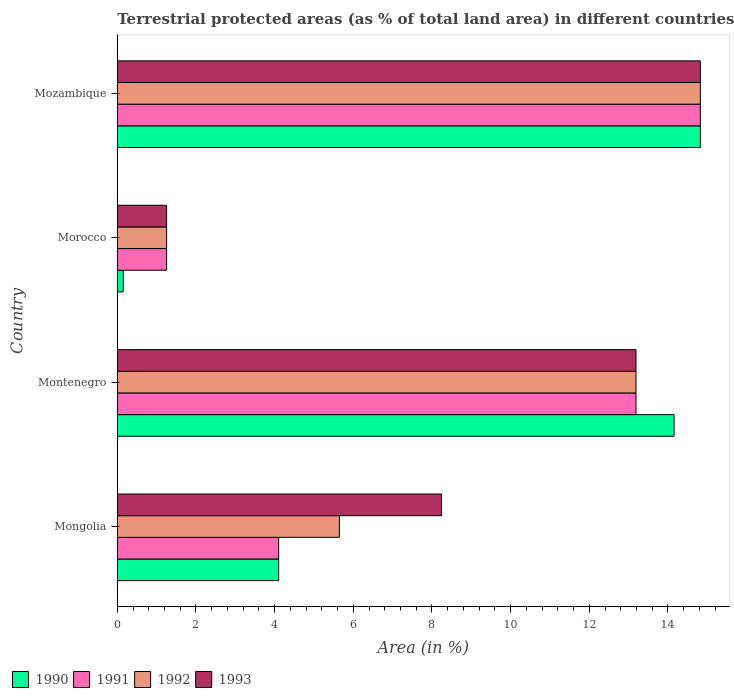How many different coloured bars are there?
Your answer should be very brief. 4. Are the number of bars on each tick of the Y-axis equal?
Ensure brevity in your answer.  Yes. What is the label of the 3rd group of bars from the top?
Offer a terse response. Montenegro. In how many cases, is the number of bars for a given country not equal to the number of legend labels?
Provide a succinct answer. 0. What is the percentage of terrestrial protected land in 1990 in Morocco?
Offer a terse response. 0.15. Across all countries, what is the maximum percentage of terrestrial protected land in 1991?
Your response must be concise. 14.82. Across all countries, what is the minimum percentage of terrestrial protected land in 1992?
Offer a very short reply. 1.25. In which country was the percentage of terrestrial protected land in 1992 maximum?
Your answer should be very brief. Mozambique. In which country was the percentage of terrestrial protected land in 1990 minimum?
Your response must be concise. Morocco. What is the total percentage of terrestrial protected land in 1993 in the graph?
Ensure brevity in your answer.  37.51. What is the difference between the percentage of terrestrial protected land in 1991 in Mongolia and that in Morocco?
Provide a short and direct response. 2.85. What is the difference between the percentage of terrestrial protected land in 1993 in Mozambique and the percentage of terrestrial protected land in 1990 in Montenegro?
Your response must be concise. 0.67. What is the average percentage of terrestrial protected land in 1992 per country?
Keep it short and to the point. 8.73. What is the difference between the percentage of terrestrial protected land in 1990 and percentage of terrestrial protected land in 1993 in Mozambique?
Offer a terse response. 0. What is the ratio of the percentage of terrestrial protected land in 1990 in Montenegro to that in Morocco?
Keep it short and to the point. 94.12. Is the percentage of terrestrial protected land in 1992 in Mongolia less than that in Mozambique?
Ensure brevity in your answer.  Yes. What is the difference between the highest and the second highest percentage of terrestrial protected land in 1990?
Your answer should be compact. 0.67. What is the difference between the highest and the lowest percentage of terrestrial protected land in 1991?
Make the answer very short. 13.57. In how many countries, is the percentage of terrestrial protected land in 1992 greater than the average percentage of terrestrial protected land in 1992 taken over all countries?
Make the answer very short. 2. Is the sum of the percentage of terrestrial protected land in 1991 in Montenegro and Morocco greater than the maximum percentage of terrestrial protected land in 1992 across all countries?
Keep it short and to the point. No. What does the 2nd bar from the top in Montenegro represents?
Provide a short and direct response. 1992. What does the 3rd bar from the bottom in Morocco represents?
Ensure brevity in your answer.  1992. Is it the case that in every country, the sum of the percentage of terrestrial protected land in 1993 and percentage of terrestrial protected land in 1991 is greater than the percentage of terrestrial protected land in 1990?
Ensure brevity in your answer.  Yes. Are all the bars in the graph horizontal?
Provide a succinct answer. Yes. How many countries are there in the graph?
Offer a terse response. 4. Are the values on the major ticks of X-axis written in scientific E-notation?
Your response must be concise. No. Does the graph contain grids?
Offer a very short reply. No. What is the title of the graph?
Your answer should be very brief. Terrestrial protected areas (as % of total land area) in different countries. What is the label or title of the X-axis?
Keep it short and to the point. Area (in %). What is the Area (in %) in 1990 in Mongolia?
Make the answer very short. 4.1. What is the Area (in %) of 1991 in Mongolia?
Offer a very short reply. 4.1. What is the Area (in %) of 1992 in Mongolia?
Your answer should be very brief. 5.65. What is the Area (in %) of 1993 in Mongolia?
Keep it short and to the point. 8.24. What is the Area (in %) of 1990 in Montenegro?
Offer a terse response. 14.15. What is the Area (in %) of 1991 in Montenegro?
Your response must be concise. 13.19. What is the Area (in %) in 1992 in Montenegro?
Your answer should be compact. 13.19. What is the Area (in %) of 1993 in Montenegro?
Your answer should be compact. 13.19. What is the Area (in %) of 1990 in Morocco?
Offer a terse response. 0.15. What is the Area (in %) of 1991 in Morocco?
Your answer should be very brief. 1.25. What is the Area (in %) of 1992 in Morocco?
Offer a very short reply. 1.25. What is the Area (in %) of 1993 in Morocco?
Your answer should be very brief. 1.25. What is the Area (in %) in 1990 in Mozambique?
Offer a very short reply. 14.82. What is the Area (in %) of 1991 in Mozambique?
Offer a very short reply. 14.82. What is the Area (in %) of 1992 in Mozambique?
Give a very brief answer. 14.82. What is the Area (in %) in 1993 in Mozambique?
Offer a very short reply. 14.82. Across all countries, what is the maximum Area (in %) of 1990?
Ensure brevity in your answer.  14.82. Across all countries, what is the maximum Area (in %) in 1991?
Provide a short and direct response. 14.82. Across all countries, what is the maximum Area (in %) of 1992?
Provide a short and direct response. 14.82. Across all countries, what is the maximum Area (in %) of 1993?
Your answer should be compact. 14.82. Across all countries, what is the minimum Area (in %) of 1990?
Your answer should be compact. 0.15. Across all countries, what is the minimum Area (in %) of 1991?
Provide a succinct answer. 1.25. Across all countries, what is the minimum Area (in %) in 1992?
Provide a short and direct response. 1.25. Across all countries, what is the minimum Area (in %) of 1993?
Your response must be concise. 1.25. What is the total Area (in %) of 1990 in the graph?
Give a very brief answer. 33.23. What is the total Area (in %) in 1991 in the graph?
Your answer should be compact. 33.37. What is the total Area (in %) of 1992 in the graph?
Offer a very short reply. 34.91. What is the total Area (in %) in 1993 in the graph?
Provide a succinct answer. 37.51. What is the difference between the Area (in %) in 1990 in Mongolia and that in Montenegro?
Keep it short and to the point. -10.05. What is the difference between the Area (in %) in 1991 in Mongolia and that in Montenegro?
Offer a very short reply. -9.08. What is the difference between the Area (in %) in 1992 in Mongolia and that in Montenegro?
Provide a succinct answer. -7.54. What is the difference between the Area (in %) of 1993 in Mongolia and that in Montenegro?
Your response must be concise. -4.94. What is the difference between the Area (in %) in 1990 in Mongolia and that in Morocco?
Provide a short and direct response. 3.95. What is the difference between the Area (in %) in 1991 in Mongolia and that in Morocco?
Your answer should be compact. 2.85. What is the difference between the Area (in %) in 1992 in Mongolia and that in Morocco?
Your answer should be very brief. 4.39. What is the difference between the Area (in %) in 1993 in Mongolia and that in Morocco?
Your answer should be compact. 6.99. What is the difference between the Area (in %) in 1990 in Mongolia and that in Mozambique?
Provide a succinct answer. -10.72. What is the difference between the Area (in %) of 1991 in Mongolia and that in Mozambique?
Provide a short and direct response. -10.72. What is the difference between the Area (in %) of 1992 in Mongolia and that in Mozambique?
Offer a terse response. -9.18. What is the difference between the Area (in %) in 1993 in Mongolia and that in Mozambique?
Offer a very short reply. -6.58. What is the difference between the Area (in %) in 1990 in Montenegro and that in Morocco?
Your response must be concise. 14. What is the difference between the Area (in %) of 1991 in Montenegro and that in Morocco?
Provide a succinct answer. 11.93. What is the difference between the Area (in %) in 1992 in Montenegro and that in Morocco?
Keep it short and to the point. 11.93. What is the difference between the Area (in %) of 1993 in Montenegro and that in Morocco?
Provide a short and direct response. 11.93. What is the difference between the Area (in %) of 1990 in Montenegro and that in Mozambique?
Your answer should be compact. -0.67. What is the difference between the Area (in %) of 1991 in Montenegro and that in Mozambique?
Offer a very short reply. -1.64. What is the difference between the Area (in %) of 1992 in Montenegro and that in Mozambique?
Make the answer very short. -1.64. What is the difference between the Area (in %) of 1993 in Montenegro and that in Mozambique?
Your answer should be compact. -1.64. What is the difference between the Area (in %) of 1990 in Morocco and that in Mozambique?
Offer a very short reply. -14.67. What is the difference between the Area (in %) in 1991 in Morocco and that in Mozambique?
Your answer should be very brief. -13.57. What is the difference between the Area (in %) in 1992 in Morocco and that in Mozambique?
Ensure brevity in your answer.  -13.57. What is the difference between the Area (in %) in 1993 in Morocco and that in Mozambique?
Your answer should be very brief. -13.57. What is the difference between the Area (in %) in 1990 in Mongolia and the Area (in %) in 1991 in Montenegro?
Ensure brevity in your answer.  -9.08. What is the difference between the Area (in %) of 1990 in Mongolia and the Area (in %) of 1992 in Montenegro?
Your answer should be very brief. -9.08. What is the difference between the Area (in %) of 1990 in Mongolia and the Area (in %) of 1993 in Montenegro?
Your answer should be very brief. -9.08. What is the difference between the Area (in %) of 1991 in Mongolia and the Area (in %) of 1992 in Montenegro?
Make the answer very short. -9.08. What is the difference between the Area (in %) in 1991 in Mongolia and the Area (in %) in 1993 in Montenegro?
Offer a very short reply. -9.08. What is the difference between the Area (in %) in 1992 in Mongolia and the Area (in %) in 1993 in Montenegro?
Provide a short and direct response. -7.54. What is the difference between the Area (in %) of 1990 in Mongolia and the Area (in %) of 1991 in Morocco?
Offer a very short reply. 2.85. What is the difference between the Area (in %) of 1990 in Mongolia and the Area (in %) of 1992 in Morocco?
Provide a succinct answer. 2.85. What is the difference between the Area (in %) in 1990 in Mongolia and the Area (in %) in 1993 in Morocco?
Offer a terse response. 2.85. What is the difference between the Area (in %) in 1991 in Mongolia and the Area (in %) in 1992 in Morocco?
Ensure brevity in your answer.  2.85. What is the difference between the Area (in %) in 1991 in Mongolia and the Area (in %) in 1993 in Morocco?
Give a very brief answer. 2.85. What is the difference between the Area (in %) in 1992 in Mongolia and the Area (in %) in 1993 in Morocco?
Offer a very short reply. 4.39. What is the difference between the Area (in %) in 1990 in Mongolia and the Area (in %) in 1991 in Mozambique?
Make the answer very short. -10.72. What is the difference between the Area (in %) in 1990 in Mongolia and the Area (in %) in 1992 in Mozambique?
Your response must be concise. -10.72. What is the difference between the Area (in %) in 1990 in Mongolia and the Area (in %) in 1993 in Mozambique?
Keep it short and to the point. -10.72. What is the difference between the Area (in %) in 1991 in Mongolia and the Area (in %) in 1992 in Mozambique?
Keep it short and to the point. -10.72. What is the difference between the Area (in %) of 1991 in Mongolia and the Area (in %) of 1993 in Mozambique?
Your answer should be compact. -10.72. What is the difference between the Area (in %) in 1992 in Mongolia and the Area (in %) in 1993 in Mozambique?
Offer a terse response. -9.18. What is the difference between the Area (in %) of 1990 in Montenegro and the Area (in %) of 1991 in Morocco?
Your answer should be very brief. 12.9. What is the difference between the Area (in %) in 1990 in Montenegro and the Area (in %) in 1992 in Morocco?
Offer a terse response. 12.9. What is the difference between the Area (in %) of 1990 in Montenegro and the Area (in %) of 1993 in Morocco?
Give a very brief answer. 12.9. What is the difference between the Area (in %) in 1991 in Montenegro and the Area (in %) in 1992 in Morocco?
Provide a short and direct response. 11.93. What is the difference between the Area (in %) in 1991 in Montenegro and the Area (in %) in 1993 in Morocco?
Provide a succinct answer. 11.93. What is the difference between the Area (in %) of 1992 in Montenegro and the Area (in %) of 1993 in Morocco?
Your answer should be very brief. 11.93. What is the difference between the Area (in %) in 1990 in Montenegro and the Area (in %) in 1991 in Mozambique?
Your response must be concise. -0.67. What is the difference between the Area (in %) in 1990 in Montenegro and the Area (in %) in 1992 in Mozambique?
Give a very brief answer. -0.67. What is the difference between the Area (in %) in 1990 in Montenegro and the Area (in %) in 1993 in Mozambique?
Make the answer very short. -0.67. What is the difference between the Area (in %) of 1991 in Montenegro and the Area (in %) of 1992 in Mozambique?
Your response must be concise. -1.64. What is the difference between the Area (in %) of 1991 in Montenegro and the Area (in %) of 1993 in Mozambique?
Provide a succinct answer. -1.64. What is the difference between the Area (in %) in 1992 in Montenegro and the Area (in %) in 1993 in Mozambique?
Make the answer very short. -1.64. What is the difference between the Area (in %) in 1990 in Morocco and the Area (in %) in 1991 in Mozambique?
Provide a succinct answer. -14.67. What is the difference between the Area (in %) in 1990 in Morocco and the Area (in %) in 1992 in Mozambique?
Offer a very short reply. -14.67. What is the difference between the Area (in %) of 1990 in Morocco and the Area (in %) of 1993 in Mozambique?
Your answer should be compact. -14.67. What is the difference between the Area (in %) of 1991 in Morocco and the Area (in %) of 1992 in Mozambique?
Your answer should be compact. -13.57. What is the difference between the Area (in %) in 1991 in Morocco and the Area (in %) in 1993 in Mozambique?
Make the answer very short. -13.57. What is the difference between the Area (in %) of 1992 in Morocco and the Area (in %) of 1993 in Mozambique?
Keep it short and to the point. -13.57. What is the average Area (in %) of 1990 per country?
Offer a very short reply. 8.31. What is the average Area (in %) of 1991 per country?
Your answer should be very brief. 8.34. What is the average Area (in %) of 1992 per country?
Offer a terse response. 8.73. What is the average Area (in %) of 1993 per country?
Ensure brevity in your answer.  9.38. What is the difference between the Area (in %) in 1990 and Area (in %) in 1991 in Mongolia?
Make the answer very short. -0. What is the difference between the Area (in %) in 1990 and Area (in %) in 1992 in Mongolia?
Ensure brevity in your answer.  -1.54. What is the difference between the Area (in %) of 1990 and Area (in %) of 1993 in Mongolia?
Give a very brief answer. -4.14. What is the difference between the Area (in %) of 1991 and Area (in %) of 1992 in Mongolia?
Keep it short and to the point. -1.54. What is the difference between the Area (in %) in 1991 and Area (in %) in 1993 in Mongolia?
Offer a very short reply. -4.14. What is the difference between the Area (in %) of 1992 and Area (in %) of 1993 in Mongolia?
Make the answer very short. -2.6. What is the difference between the Area (in %) in 1990 and Area (in %) in 1991 in Montenegro?
Provide a short and direct response. 0.97. What is the difference between the Area (in %) of 1990 and Area (in %) of 1992 in Montenegro?
Your response must be concise. 0.97. What is the difference between the Area (in %) in 1991 and Area (in %) in 1993 in Montenegro?
Provide a short and direct response. 0. What is the difference between the Area (in %) of 1990 and Area (in %) of 1991 in Morocco?
Provide a succinct answer. -1.1. What is the difference between the Area (in %) in 1990 and Area (in %) in 1992 in Morocco?
Your answer should be compact. -1.1. What is the difference between the Area (in %) in 1990 and Area (in %) in 1993 in Morocco?
Your answer should be compact. -1.1. What is the difference between the Area (in %) of 1991 and Area (in %) of 1992 in Morocco?
Offer a terse response. 0. What is the difference between the Area (in %) in 1992 and Area (in %) in 1993 in Morocco?
Give a very brief answer. 0. What is the difference between the Area (in %) in 1990 and Area (in %) in 1991 in Mozambique?
Make the answer very short. 0. What is the difference between the Area (in %) in 1990 and Area (in %) in 1992 in Mozambique?
Provide a succinct answer. 0. What is the difference between the Area (in %) in 1990 and Area (in %) in 1993 in Mozambique?
Provide a succinct answer. 0. What is the difference between the Area (in %) of 1992 and Area (in %) of 1993 in Mozambique?
Offer a very short reply. 0. What is the ratio of the Area (in %) in 1990 in Mongolia to that in Montenegro?
Ensure brevity in your answer.  0.29. What is the ratio of the Area (in %) of 1991 in Mongolia to that in Montenegro?
Your response must be concise. 0.31. What is the ratio of the Area (in %) of 1992 in Mongolia to that in Montenegro?
Provide a succinct answer. 0.43. What is the ratio of the Area (in %) in 1993 in Mongolia to that in Montenegro?
Keep it short and to the point. 0.63. What is the ratio of the Area (in %) in 1990 in Mongolia to that in Morocco?
Keep it short and to the point. 27.28. What is the ratio of the Area (in %) in 1991 in Mongolia to that in Morocco?
Your answer should be very brief. 3.27. What is the ratio of the Area (in %) in 1992 in Mongolia to that in Morocco?
Keep it short and to the point. 4.5. What is the ratio of the Area (in %) of 1993 in Mongolia to that in Morocco?
Your answer should be very brief. 6.57. What is the ratio of the Area (in %) in 1990 in Mongolia to that in Mozambique?
Offer a very short reply. 0.28. What is the ratio of the Area (in %) of 1991 in Mongolia to that in Mozambique?
Provide a succinct answer. 0.28. What is the ratio of the Area (in %) of 1992 in Mongolia to that in Mozambique?
Offer a very short reply. 0.38. What is the ratio of the Area (in %) in 1993 in Mongolia to that in Mozambique?
Offer a terse response. 0.56. What is the ratio of the Area (in %) in 1990 in Montenegro to that in Morocco?
Your answer should be very brief. 94.12. What is the ratio of the Area (in %) in 1991 in Montenegro to that in Morocco?
Keep it short and to the point. 10.52. What is the ratio of the Area (in %) in 1992 in Montenegro to that in Morocco?
Give a very brief answer. 10.52. What is the ratio of the Area (in %) in 1993 in Montenegro to that in Morocco?
Provide a short and direct response. 10.52. What is the ratio of the Area (in %) of 1990 in Montenegro to that in Mozambique?
Offer a very short reply. 0.95. What is the ratio of the Area (in %) in 1991 in Montenegro to that in Mozambique?
Provide a short and direct response. 0.89. What is the ratio of the Area (in %) in 1992 in Montenegro to that in Mozambique?
Offer a terse response. 0.89. What is the ratio of the Area (in %) in 1993 in Montenegro to that in Mozambique?
Your answer should be compact. 0.89. What is the ratio of the Area (in %) of 1990 in Morocco to that in Mozambique?
Your answer should be very brief. 0.01. What is the ratio of the Area (in %) of 1991 in Morocco to that in Mozambique?
Offer a terse response. 0.08. What is the ratio of the Area (in %) of 1992 in Morocco to that in Mozambique?
Provide a short and direct response. 0.08. What is the ratio of the Area (in %) in 1993 in Morocco to that in Mozambique?
Offer a very short reply. 0.08. What is the difference between the highest and the second highest Area (in %) in 1990?
Your answer should be compact. 0.67. What is the difference between the highest and the second highest Area (in %) of 1991?
Provide a short and direct response. 1.64. What is the difference between the highest and the second highest Area (in %) in 1992?
Keep it short and to the point. 1.64. What is the difference between the highest and the second highest Area (in %) of 1993?
Provide a short and direct response. 1.64. What is the difference between the highest and the lowest Area (in %) of 1990?
Offer a very short reply. 14.67. What is the difference between the highest and the lowest Area (in %) in 1991?
Ensure brevity in your answer.  13.57. What is the difference between the highest and the lowest Area (in %) of 1992?
Your answer should be very brief. 13.57. What is the difference between the highest and the lowest Area (in %) in 1993?
Give a very brief answer. 13.57. 